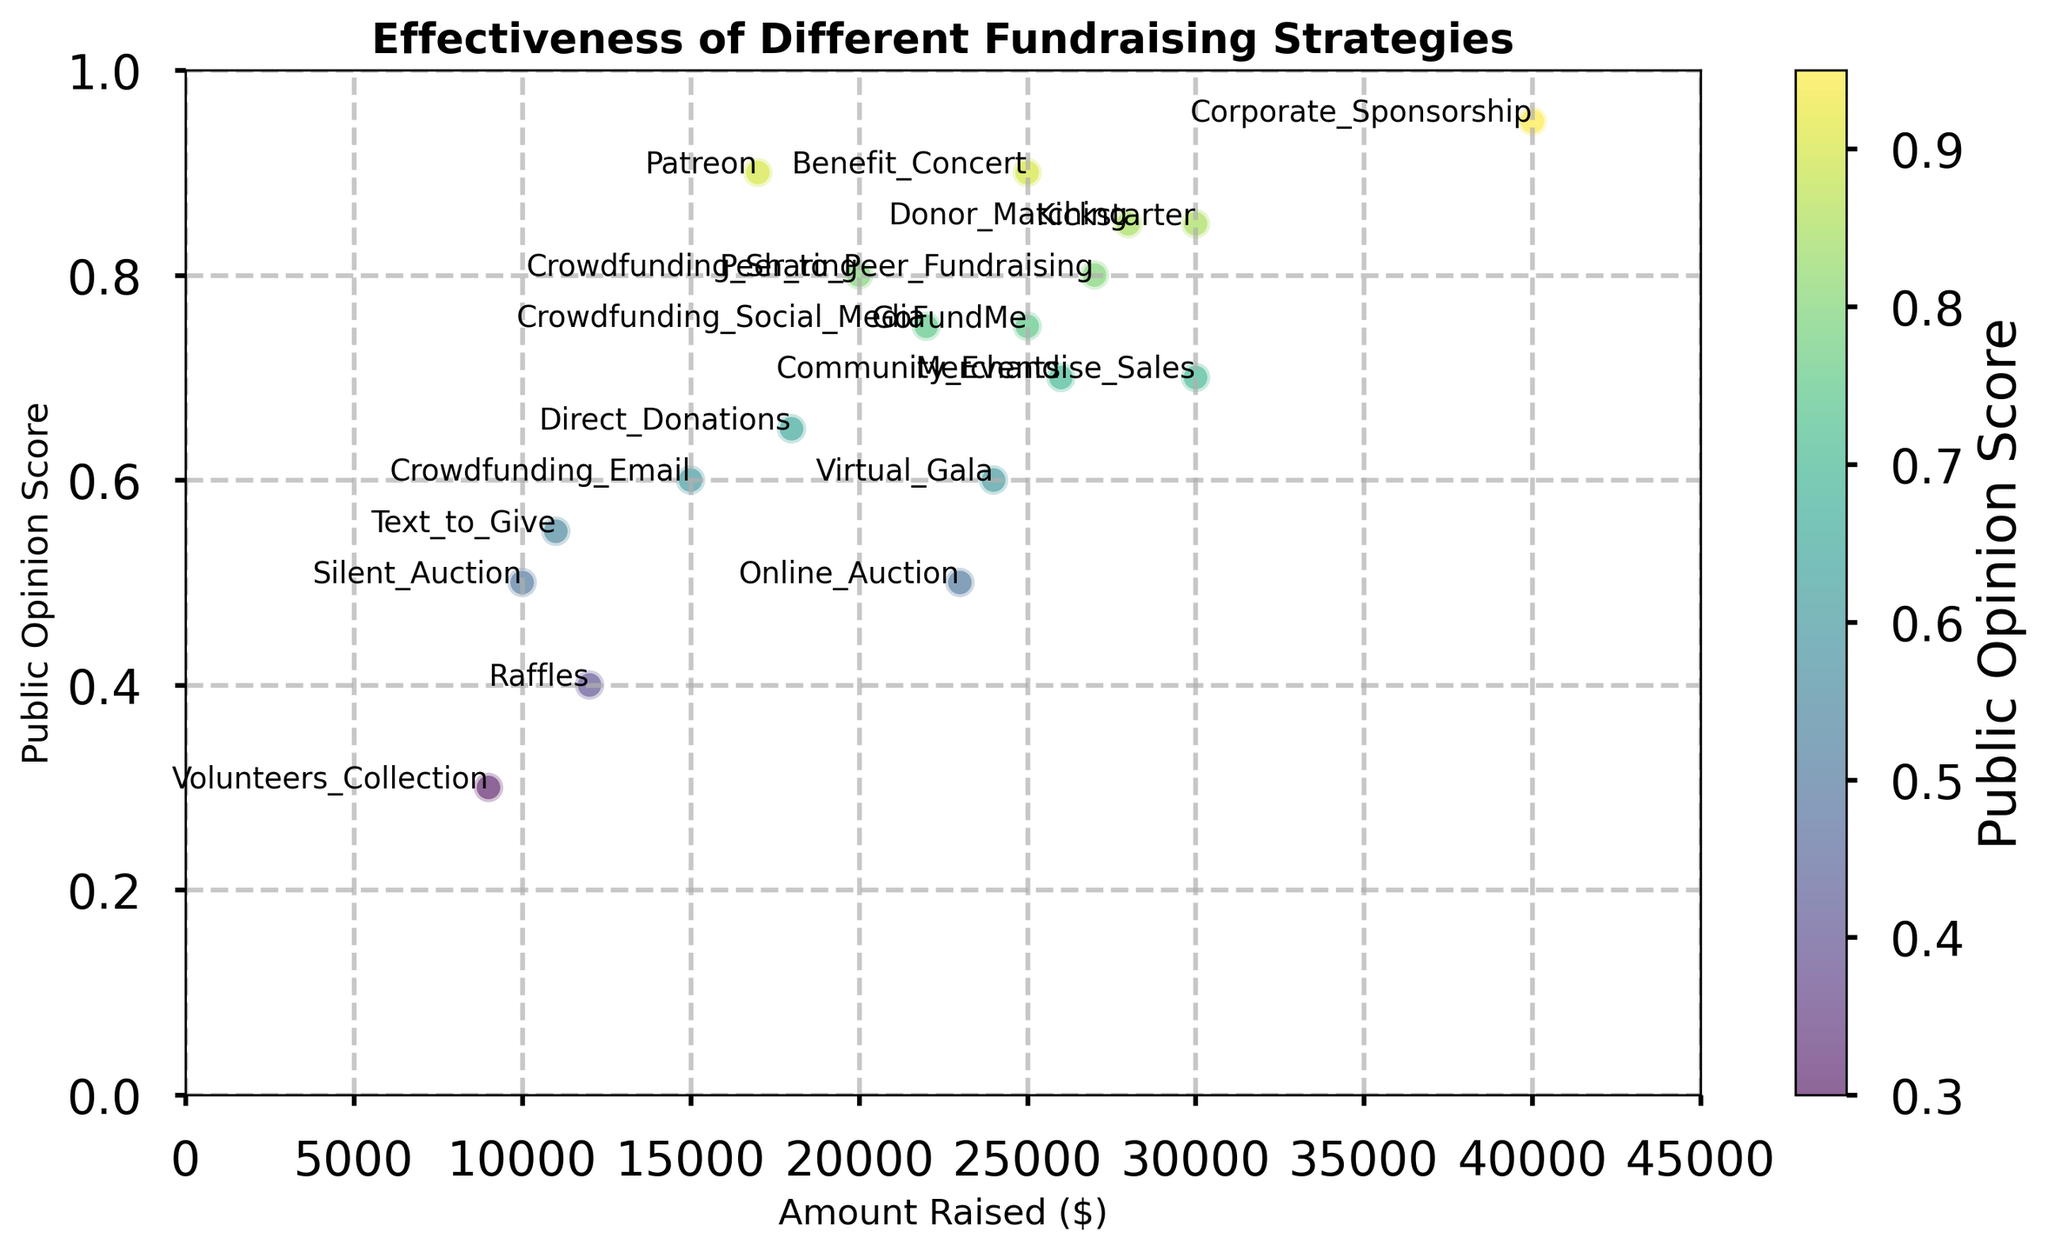What's the highest amount raised and which strategy achieved it? The scatter plot shows the amount raised along the x-axis. The strategy that achieved the highest amount raised is Corporate_Sponsorship with $40,000.
Answer: Corporate_Sponsorship Which strategy has the lowest public opinion score, and what is that score? The y-axis of the scatter plot represents the public opinion score. Volunteers_Collection has the lowest public opinion score at 0.3.
Answer: Volunteers_Collection, 0.3 Which strategy raised more money, "Benefit Concert" or "Crowdfunding Sharing"? By comparing the x-axis positions of Benefit Concert and Crowdfunding Sharing, Benefit Concert raised $25,000 while Crowdfunding Sharing raised $20,000. Therefore, Benefit Concert raised more money.
Answer: Benefit Concert What is the public opinion score for the strategy that raised $30,000? There are two strategies that raised $30,000, Merchandise_Sales and Kickstarter. Merchandise_Sales has a public opinion score of 0.7 while Kickstarter has a score of 0.85.
Answer: 0.7, 0.85 Which strategy has the highest public opinion score, and what is the amount it raised? The highest public opinion score on the y-axis is 0.95, achieved by Corporate_Sponsorship which raised $40,000.
Answer: Corporate_Sponsorship, $40,000 List all strategies with a public opinion score of 0.75. On the y-axis, the 0.75 score is shared by Crowdfunding_Social_Media and GoFundMe.
Answer: Crowdfunding_Social_Media, GoFundMe What is the difference in the amount raised between "Donor Matching" and "Patreon"? Donor Matching raised $28,000 and Patreon raised $17,000. The difference is $28,000 - $17,000 = $11,000.
Answer: $11,000 Which strategies are located in the quartile with the highest public opinion score? The highest quartile for public opinion score contains strategies with scores from 0.75 to 0.95. Strategies include Corporate_Sponsorship, Benefit_Concert, Donor_Matching, Crowdfunding_Sharing, Crowdfunding_Social_Media, GoFundMe, Peer_to_Peer_Fundraising, and Kickstarter.
Answer: Corporate_Sponsorship, Benefit_Concert, Donor_Matching, Crowdfunding_Sharing, Crowdfunding_Social_Media, GoFundMe, Peer_to_Peer_Fundraising, Kickstarter What is the total amount raised by strategies with a public opinion score above 0.8? The strategies with scores above 0.8 are: Crowdfunding_Sharing ($20,000), Benefit_Concert ($25,000), Donor_Matching ($28,000), Kickstarter ($30,000), Peer_to_Peer_Fundraising ($27,000), and Corporate_Sponsorship ($40,000). The total is $20,000 + $25,000 + $28,000 + $30,000 + $27,000 + $40,000 = $170,000.
Answer: $170,000 